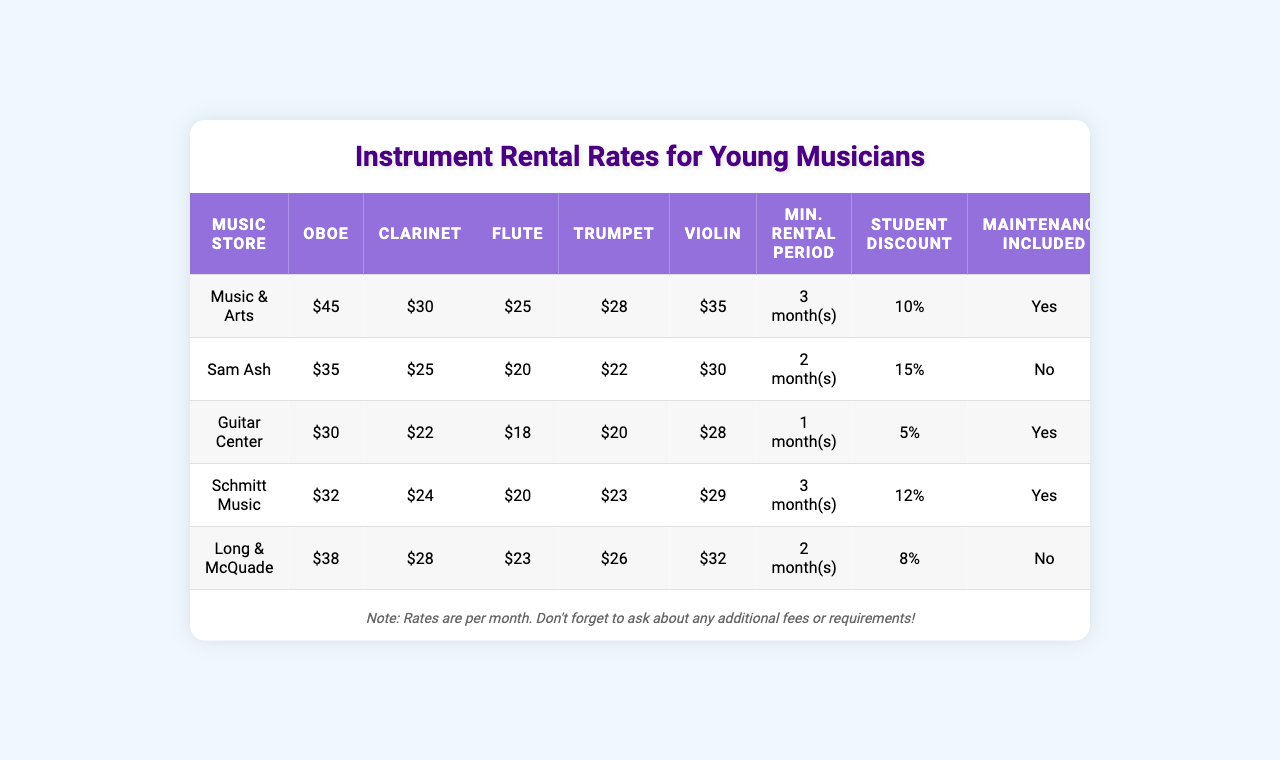What is the rental rate for an oboe at Music & Arts? The table shows that the rental rate for an oboe at Music & Arts is $45.
Answer: $45 Which store has the lowest rental rate for a flute? Looking at the flute rental rates, Guitar Center has the lowest rate at $18.
Answer: Guitar Center What percentage is the student discount at Sam Ash? The student discount percentage listed for Sam Ash in the table is 15%.
Answer: 15% Is maintenance included in the rental for the clarinet at Schmitt Music? The table indicates that maintenance is included in the rental agreement for the clarinet at Schmitt Music.
Answer: Yes What instrument rental has the highest rate at Long & McQuade? Checking the rates for Long & McQuade, the highest rental rate is for the trumpet at $26.
Answer: Trumpet What is the total monthly rental cost for renting an oboe at Guitar Center, including insurance? The oboe rental rate at Guitar Center is $30, and the insurance cost is $6. Therefore, the total cost is $30 + $6 = $36.
Answer: $36 Which store has the longest minimum rental period and what is it? Scanning the minimum rental periods, both Music & Arts and Schmitt Music have the longest minimum rental period of 3 months, which is greater than any other store.
Answer: 3 months What is the average rental rate for the violin across all stores? The rental rates for the violin are $35, $30, $28, $29, and $32. Adding these rates gives  $35 + $30 + $28 + $29 + $32 = 154, and dividing by 5 results in an average of 154 / 5 = 30.8.
Answer: $30.80 Which store offers the highest insurance cost per month, and how much is it? Long & McQuade has the highest insurance cost per month at $8.
Answer: $8 If a young musician rents a clarinet at Schmitt Music for 3 months, how much would the total rental cost be after applying the student discount? The rental rate for a clarinet at Schmitt Music is $24 per month. For 3 months, the cost would be 3 * $24 = $72. Applying the 12% student discount results in a discount amount of $72 * 0.12 = $8.64. Therefore, the total after the discount is $72 - $8.64 = $63.36.
Answer: $63.36 